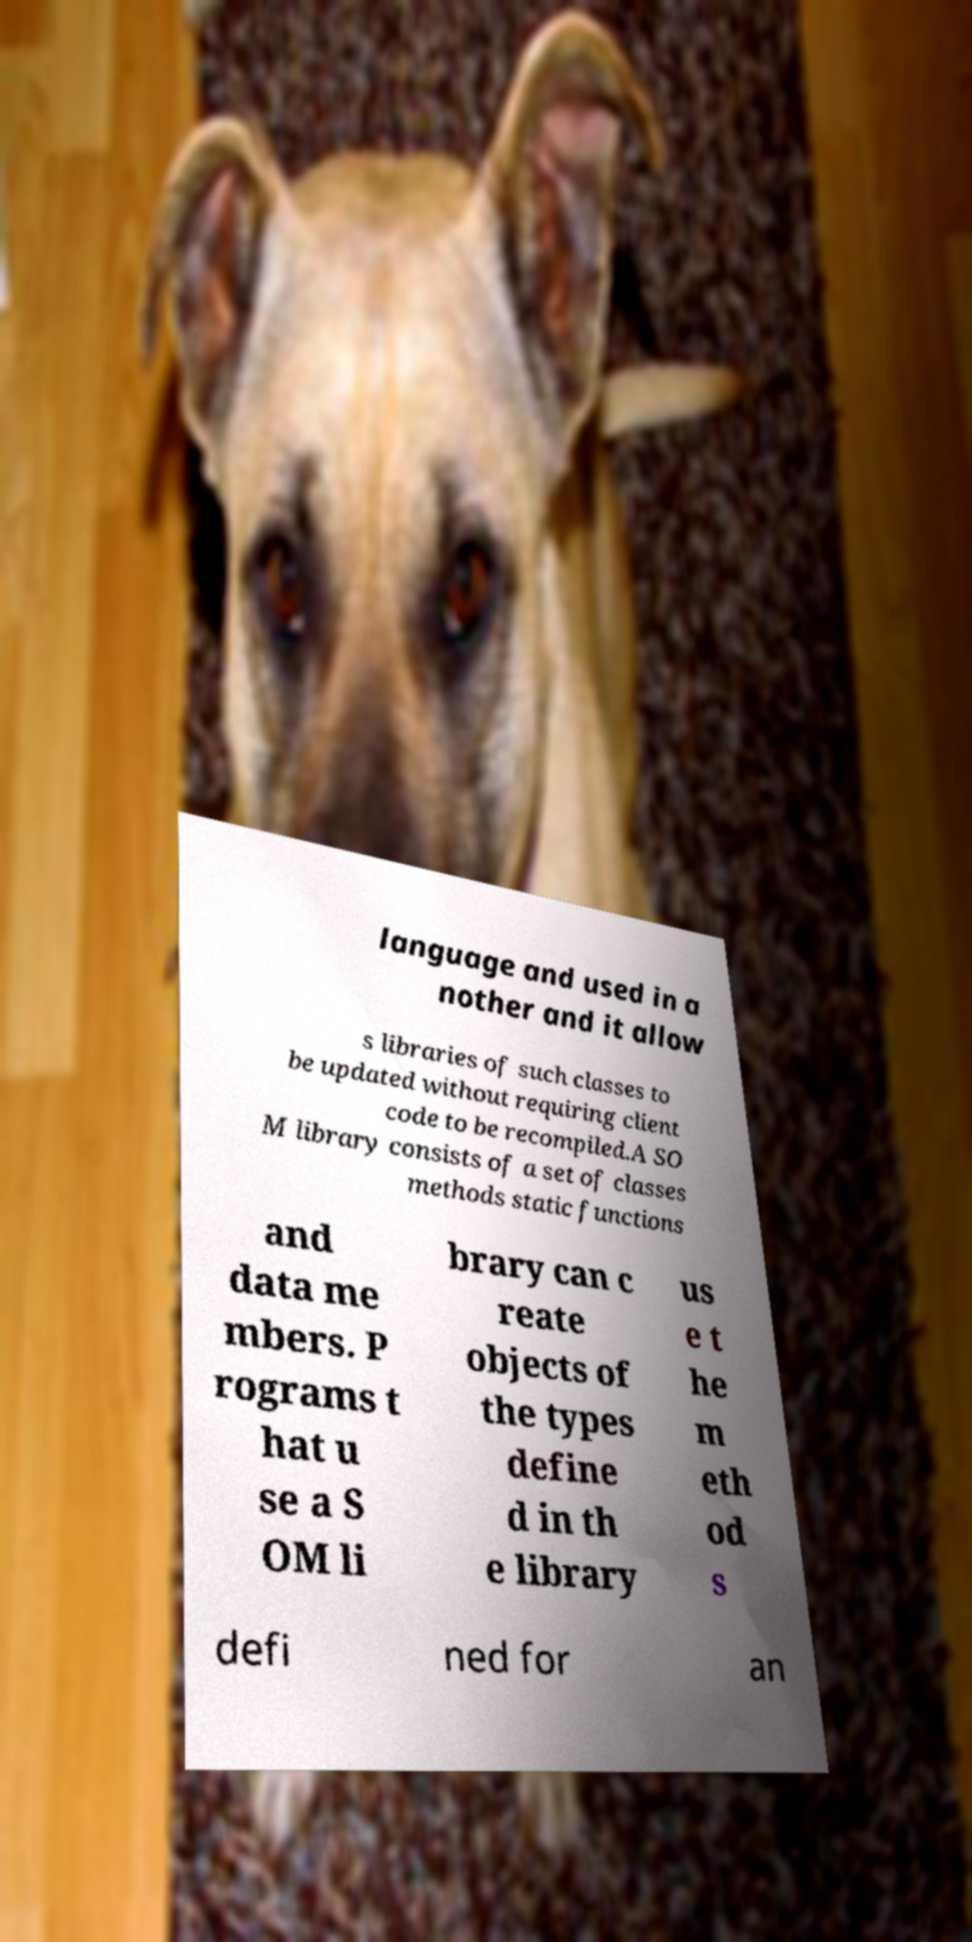Please read and relay the text visible in this image. What does it say? language and used in a nother and it allow s libraries of such classes to be updated without requiring client code to be recompiled.A SO M library consists of a set of classes methods static functions and data me mbers. P rograms t hat u se a S OM li brary can c reate objects of the types define d in th e library us e t he m eth od s defi ned for an 